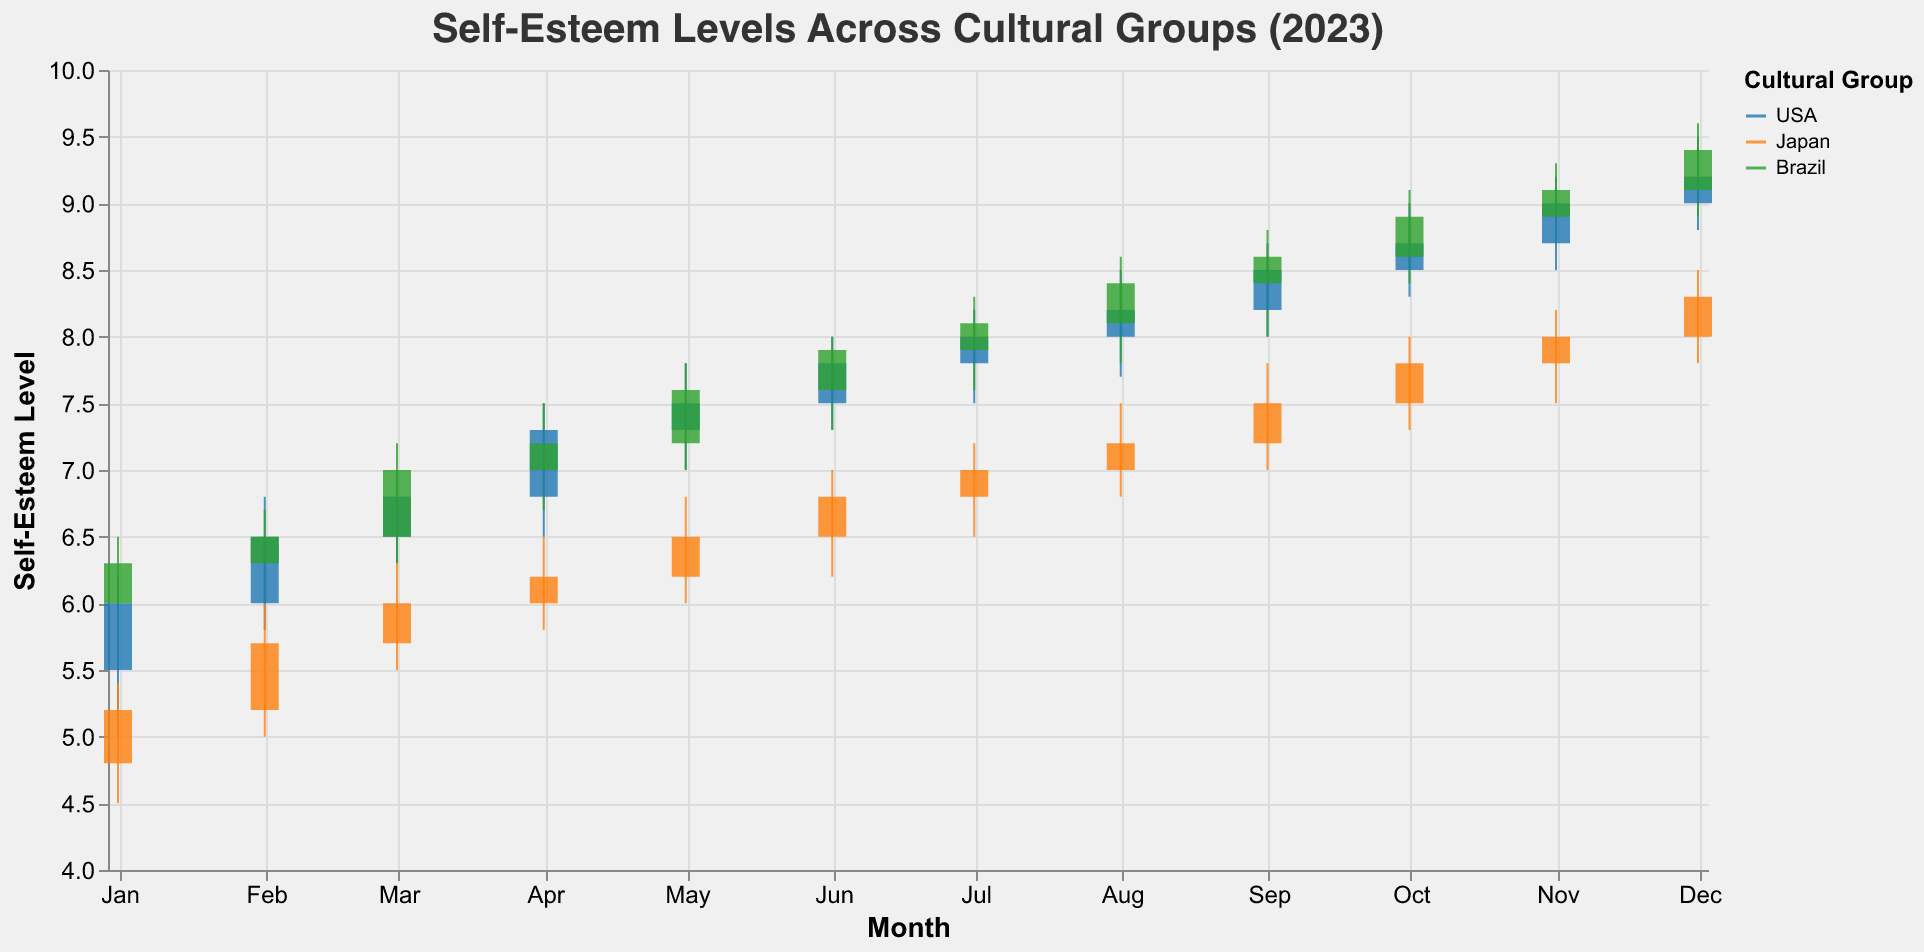What is the title of the plot? The title of the plot is located at the top and provides an overview of the data being depicted.
Answer: Self-Esteem Levels Across Cultural Groups (2023) How many cultural groups are represented in the plot? The legend indicates the different cultural groups included in the plot.
Answer: Three For which cultural group does the self-esteem level start the lowest in January? Look at the opening values for January and compare them across the cultural groups. Japan has the lowest opening value with 4.8.
Answer: Japan What was the highest self-esteem level reached by Brazil throughout the year? Look at all the high values for Brazil in each month and find the maximum value. The highest value reached was 9.6 in December.
Answer: 9.6 Between which two months did the USA show the greatest increase in closing self-esteem level? Examine the closing values for the USA for each month and find the two consecutive months with the largest difference. From January to February, the USA increased from 6.0 to 6.5 (5.5 = 6.5 - 6.0), which is the largest increase.
Answer: January to February Which group had the most stable (least variation) self-esteem levels in April? Compare the high and low values for each group in April; the smallest difference indicates the most stability. Japan's values range from 5.8 to 6.5, showing the least variation.
Answer: Japan During which month did the self-esteem level of Japan close at 8.3? Look for the month where Japan's closing value was 8.3. The closing value for Japan was 8.3 in December.
Answer: December How did Brazil's self-esteem change from July to August? Compare the closing values for Brazil in July and August. Brazil's close value increases from 8.1 in July to 8.4 in August, indicating an increase.
Answer: Increased By how much did the self-esteem level of the USA increase from June to December? Subtract the closing value in June from the closing value in December. The value goes from 7.8 in June to 9.2 in December, so the increase is 1.4.
Answer: 1.4 Which cultural group had the highest closing self-esteem level in December? Look at December's data and compare the closing values for each group. Brazil had the highest closing value of 9.4.
Answer: Brazil 